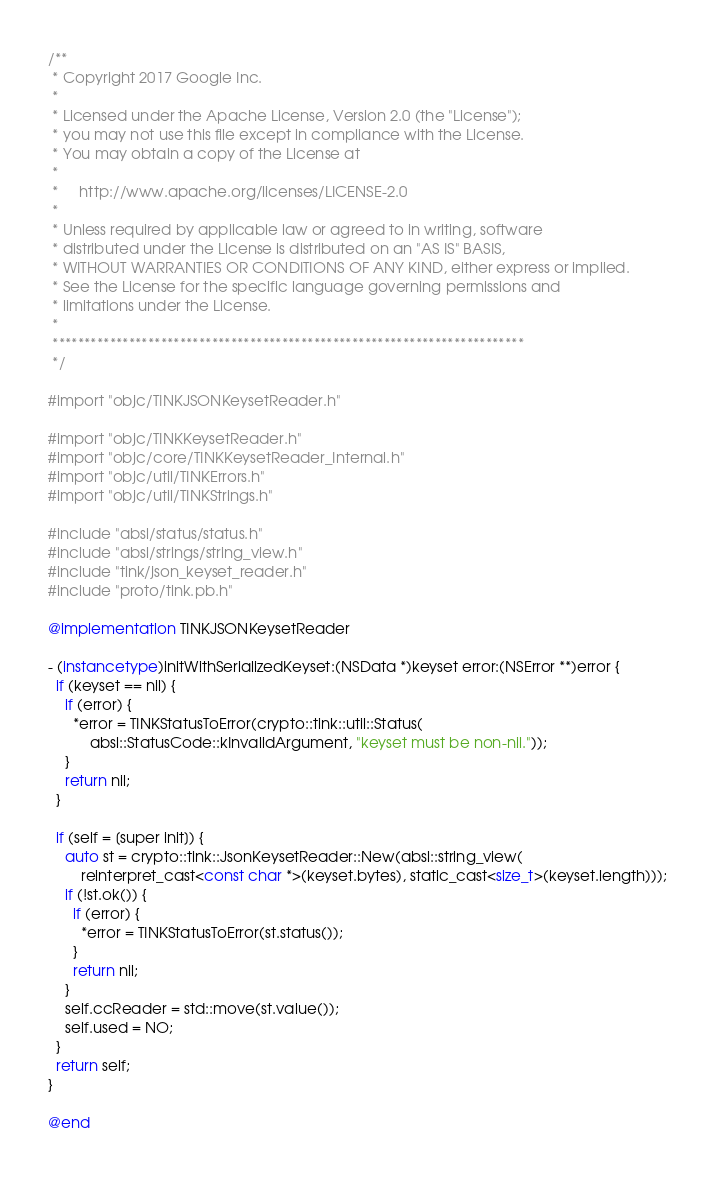Convert code to text. <code><loc_0><loc_0><loc_500><loc_500><_ObjectiveC_>/**
 * Copyright 2017 Google Inc.
 *
 * Licensed under the Apache License, Version 2.0 (the "License");
 * you may not use this file except in compliance with the License.
 * You may obtain a copy of the License at
 *
 *     http://www.apache.org/licenses/LICENSE-2.0
 *
 * Unless required by applicable law or agreed to in writing, software
 * distributed under the License is distributed on an "AS IS" BASIS,
 * WITHOUT WARRANTIES OR CONDITIONS OF ANY KIND, either express or implied.
 * See the License for the specific language governing permissions and
 * limitations under the License.
 *
 **************************************************************************
 */

#import "objc/TINKJSONKeysetReader.h"

#import "objc/TINKKeysetReader.h"
#import "objc/core/TINKKeysetReader_Internal.h"
#import "objc/util/TINKErrors.h"
#import "objc/util/TINKStrings.h"

#include "absl/status/status.h"
#include "absl/strings/string_view.h"
#include "tink/json_keyset_reader.h"
#include "proto/tink.pb.h"

@implementation TINKJSONKeysetReader

- (instancetype)initWithSerializedKeyset:(NSData *)keyset error:(NSError **)error {
  if (keyset == nil) {
    if (error) {
      *error = TINKStatusToError(crypto::tink::util::Status(
          absl::StatusCode::kInvalidArgument, "keyset must be non-nil."));
    }
    return nil;
  }

  if (self = [super init]) {
    auto st = crypto::tink::JsonKeysetReader::New(absl::string_view(
        reinterpret_cast<const char *>(keyset.bytes), static_cast<size_t>(keyset.length)));
    if (!st.ok()) {
      if (error) {
        *error = TINKStatusToError(st.status());
      }
      return nil;
    }
    self.ccReader = std::move(st.value());
    self.used = NO;
  }
  return self;
}

@end
</code> 